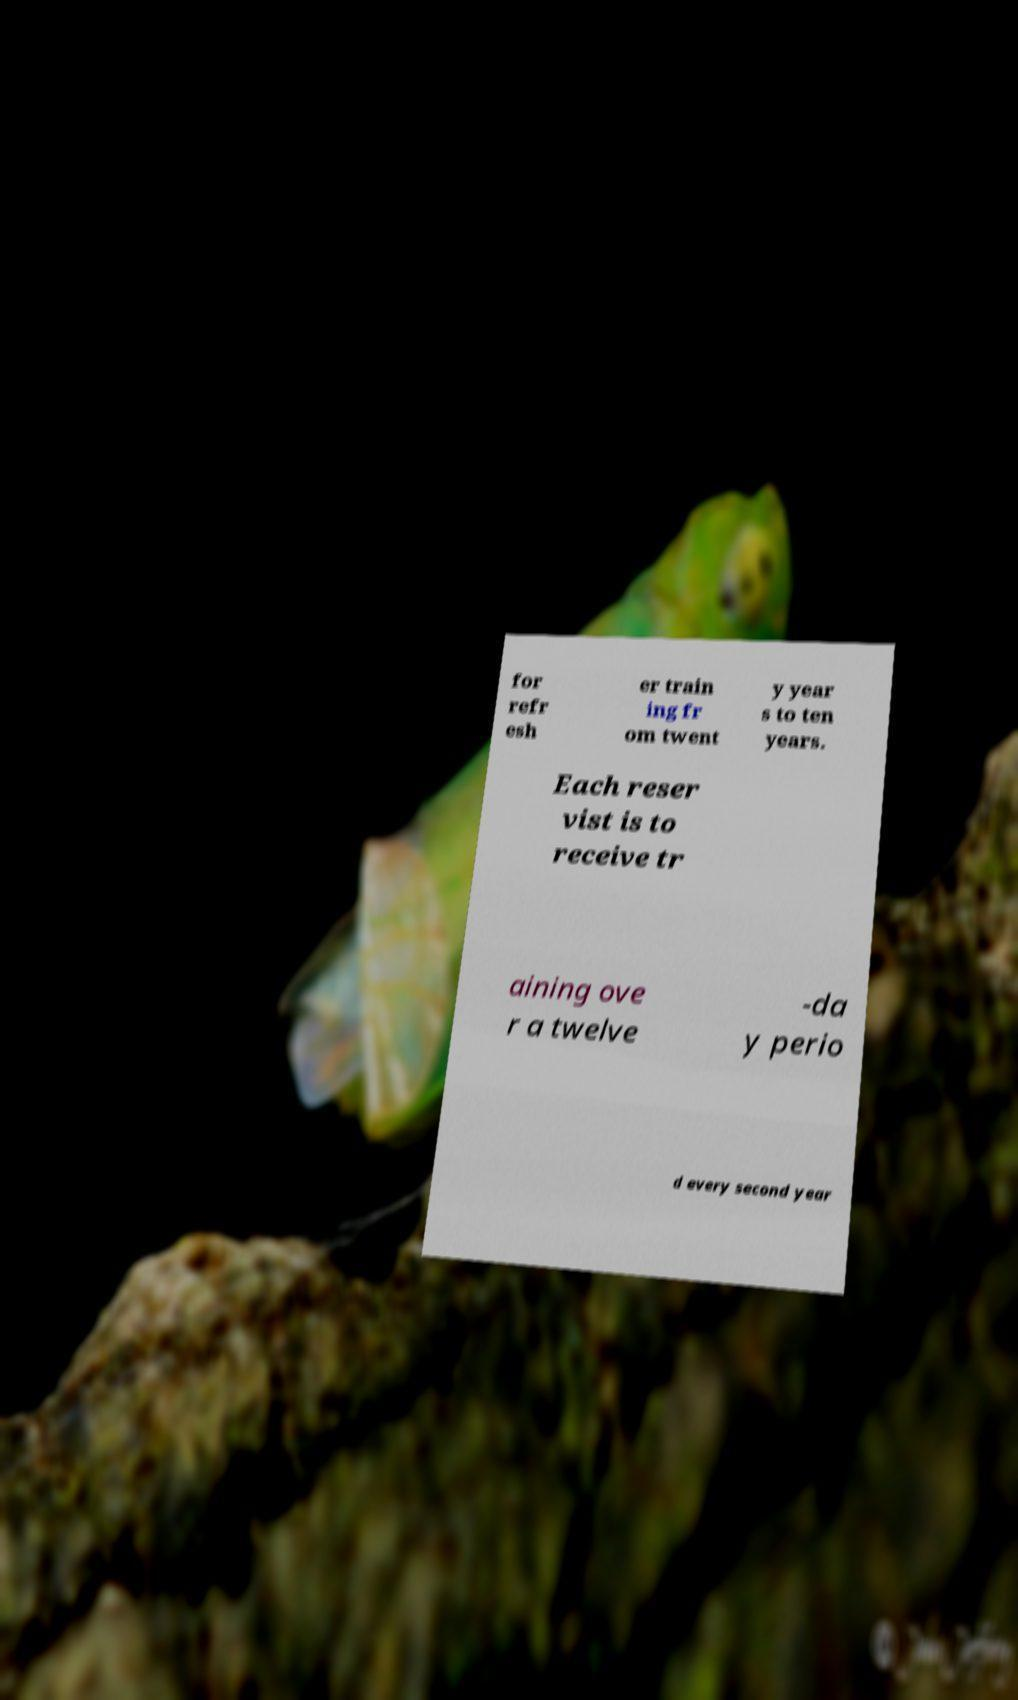Please identify and transcribe the text found in this image. for refr esh er train ing fr om twent y year s to ten years. Each reser vist is to receive tr aining ove r a twelve -da y perio d every second year 